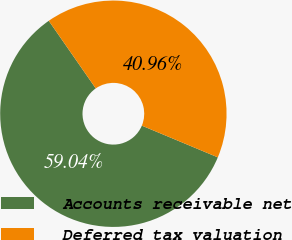<chart> <loc_0><loc_0><loc_500><loc_500><pie_chart><fcel>Accounts receivable net<fcel>Deferred tax valuation<nl><fcel>59.04%<fcel>40.96%<nl></chart> 